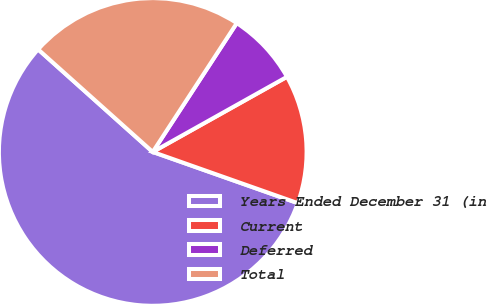Convert chart. <chart><loc_0><loc_0><loc_500><loc_500><pie_chart><fcel>Years Ended December 31 (in<fcel>Current<fcel>Deferred<fcel>Total<nl><fcel>56.22%<fcel>13.52%<fcel>7.68%<fcel>22.58%<nl></chart> 